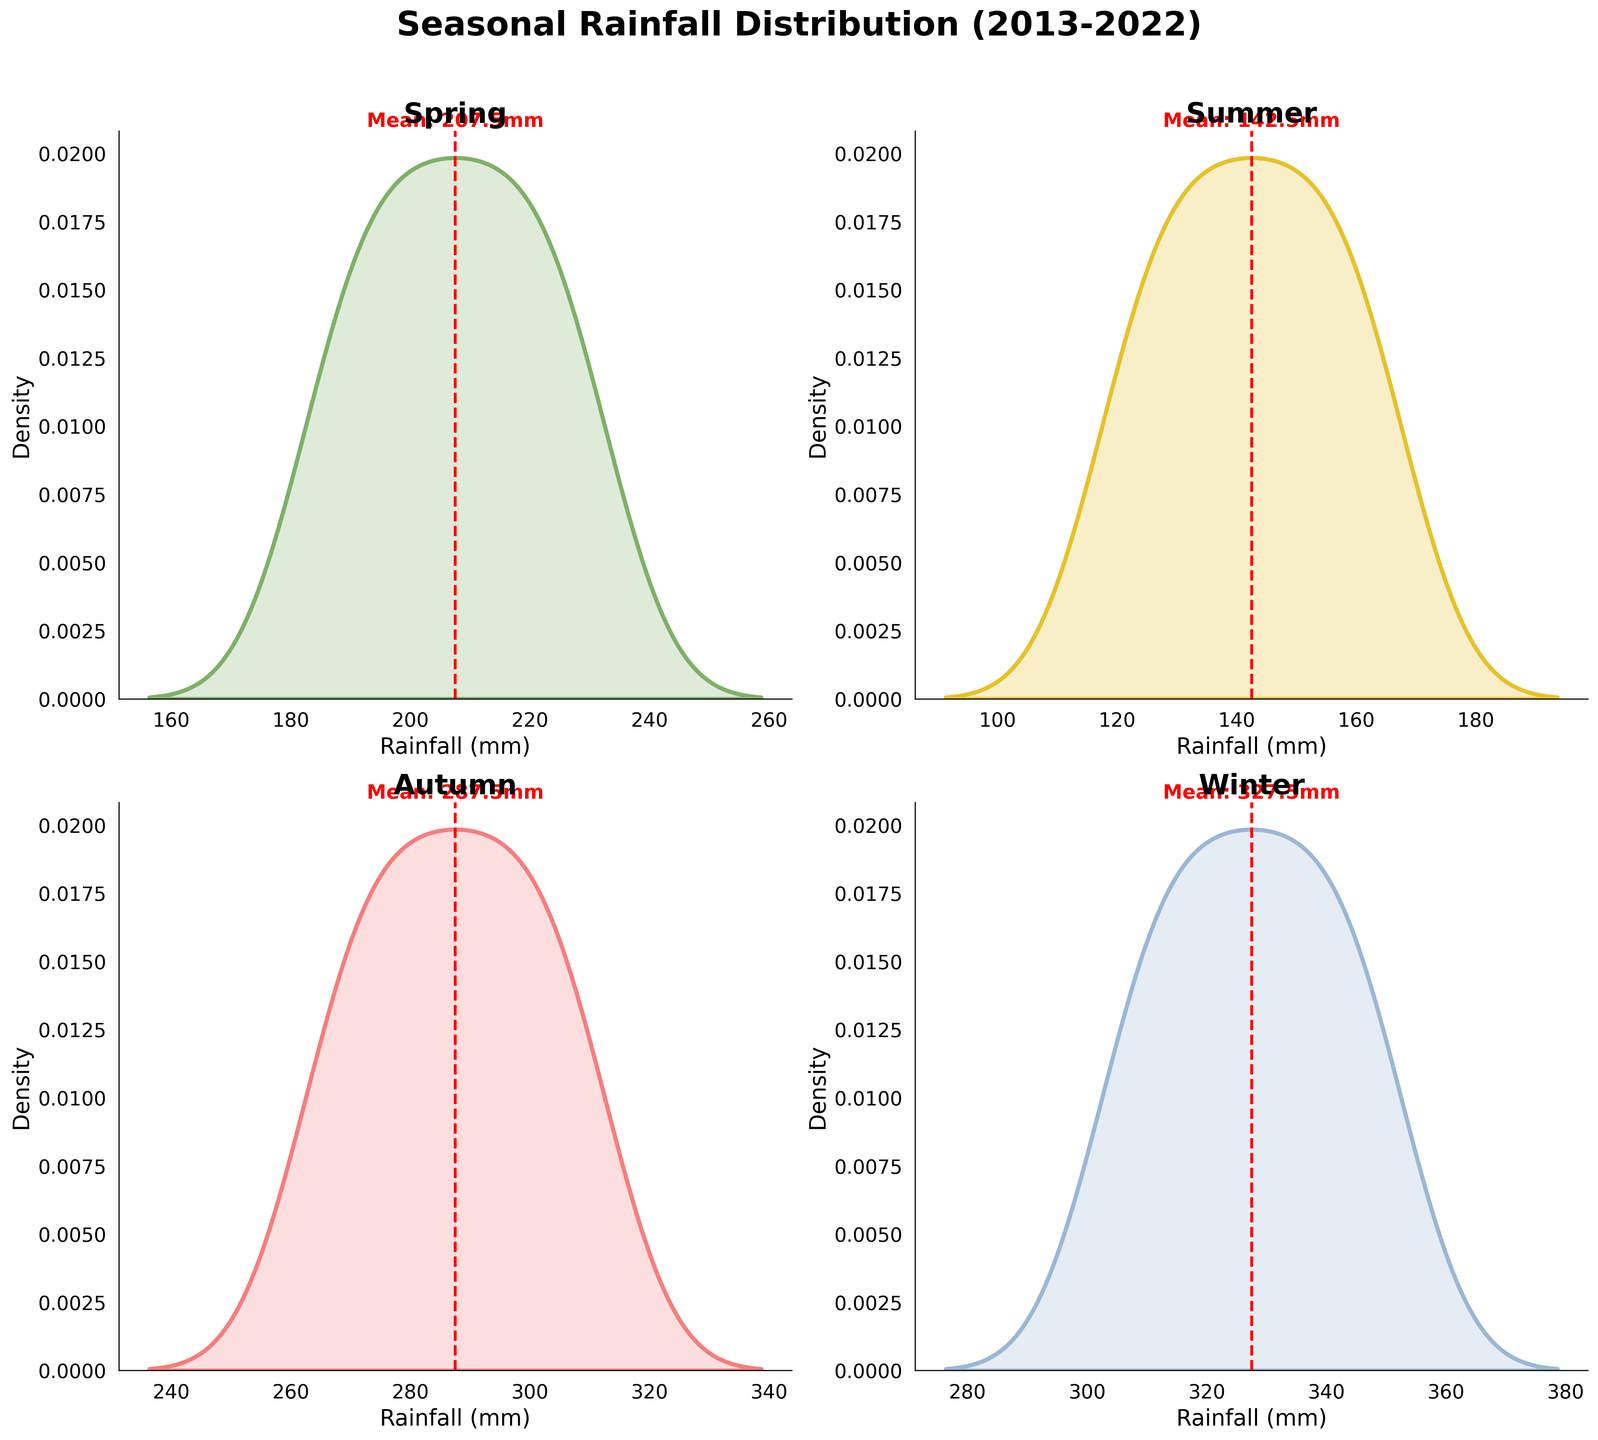How many density plots are there in the figure? The figure consists of subplots for each season to show rainfall distribution. Each subplot corresponds to one season. Spring, Summer, Autumn, and Winter are all represented.
Answer: 4 What is the title of the figure? The title is positioned at the top of the figure and summarizes the content.
Answer: Seasonal Rainfall Distribution (2013-2022) Which season has the highest mean rainfall? The mean rainfall value is depicted with a red dashed vertical line in each subplot. The Winter plot has the highest mean rainfall as indicated by the position of the line.
Answer: Winter What is the mean rainfall for Summer? In the Summer density plot, the red dashed vertical line marks the mean value, and next to it, a text annotation states the exact value. The mean rainfall is marked as 141.5mm.
Answer: 141.5mm Which season shows the most variation in rainfall? The variation in rainfall can be inferred from the spread of the density plot. A wider spread indicates more variation. The Winter plot shows the most variation due to its wider spread compared to the others.
Answer: Winter What does the red dashed vertical line represent in each subplot? In each subplot, this line indicates the mean rainfall value for that season, with the exact value annotated next to the line.
Answer: Mean rainfall What is the color associated with the Spring density plot? The Spring density plot is filled with a unique color different from other seasons. It is the first plot in the upper left corner.
Answer: Green Between Autumn and Spring, which season has a higher peak density? The peak density can be identified by the tallest point in the density plot. Compare the height of the tallest points of the Autumn and Spring plots. Autumn has a higher peak.
Answer: Autumn How does the rainfall in 2018 compare to the overall pattern for Winter? The rainfall in Winter for 2018 is 330mm. By comparing this value to the density plot for Winter which highlights the distribution, 330mm appears slightly above average for Winter.
Answer: Above average Which season’s density curve is the flattest? A flatter curve indicates less variation in the data, spreading more uniformly. The Summer density plot is the flattest, showing a relatively small range of variation.
Answer: Summer 